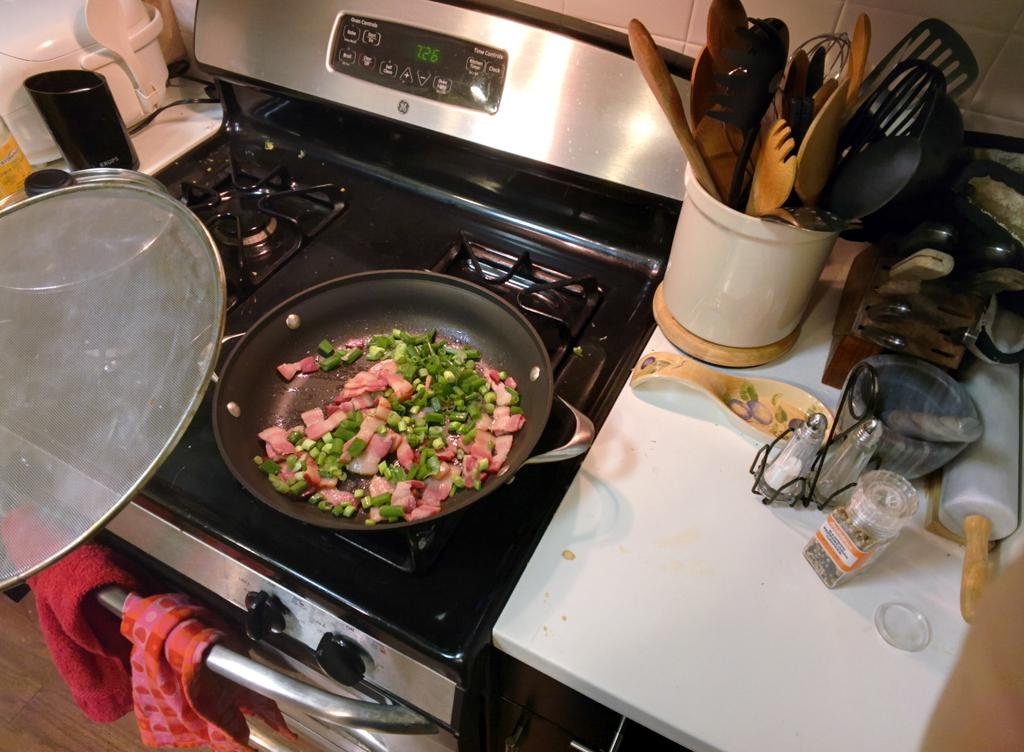Provide a one-sentence caption for the provided image. Cut up ham and scallons cooking in a pay on the stove. 